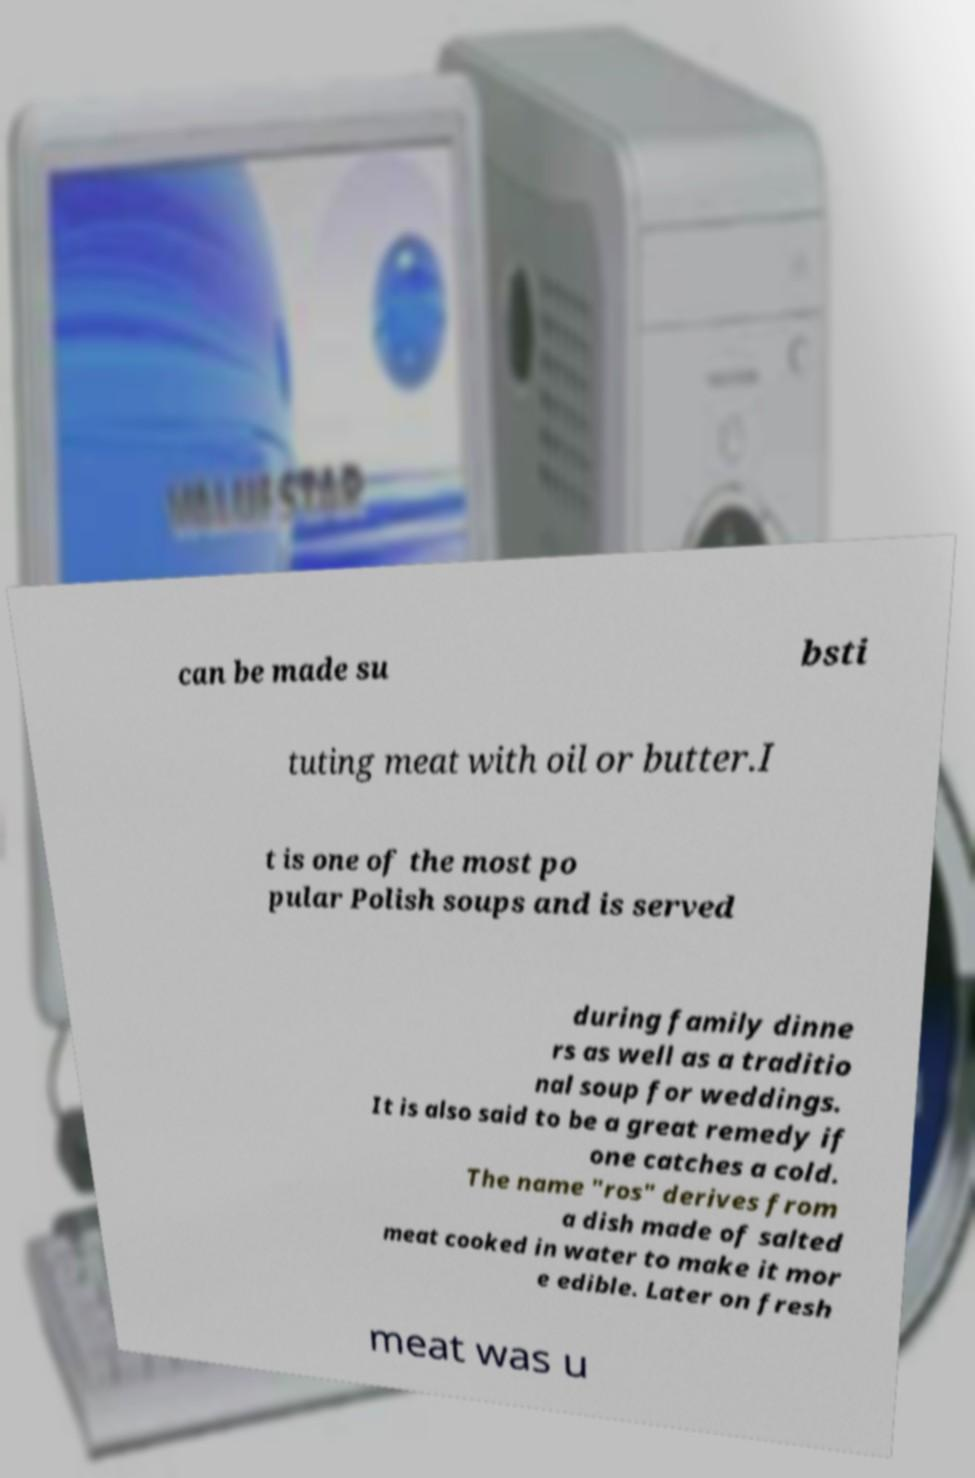Could you extract and type out the text from this image? can be made su bsti tuting meat with oil or butter.I t is one of the most po pular Polish soups and is served during family dinne rs as well as a traditio nal soup for weddings. It is also said to be a great remedy if one catches a cold. The name "ros" derives from a dish made of salted meat cooked in water to make it mor e edible. Later on fresh meat was u 